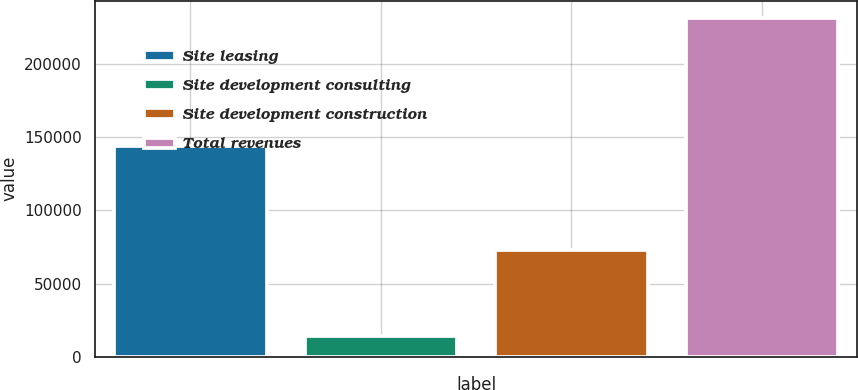Convert chart to OTSL. <chart><loc_0><loc_0><loc_500><loc_500><bar_chart><fcel>Site leasing<fcel>Site development consulting<fcel>Site development construction<fcel>Total revenues<nl><fcel>144004<fcel>14456<fcel>73022<fcel>231482<nl></chart> 